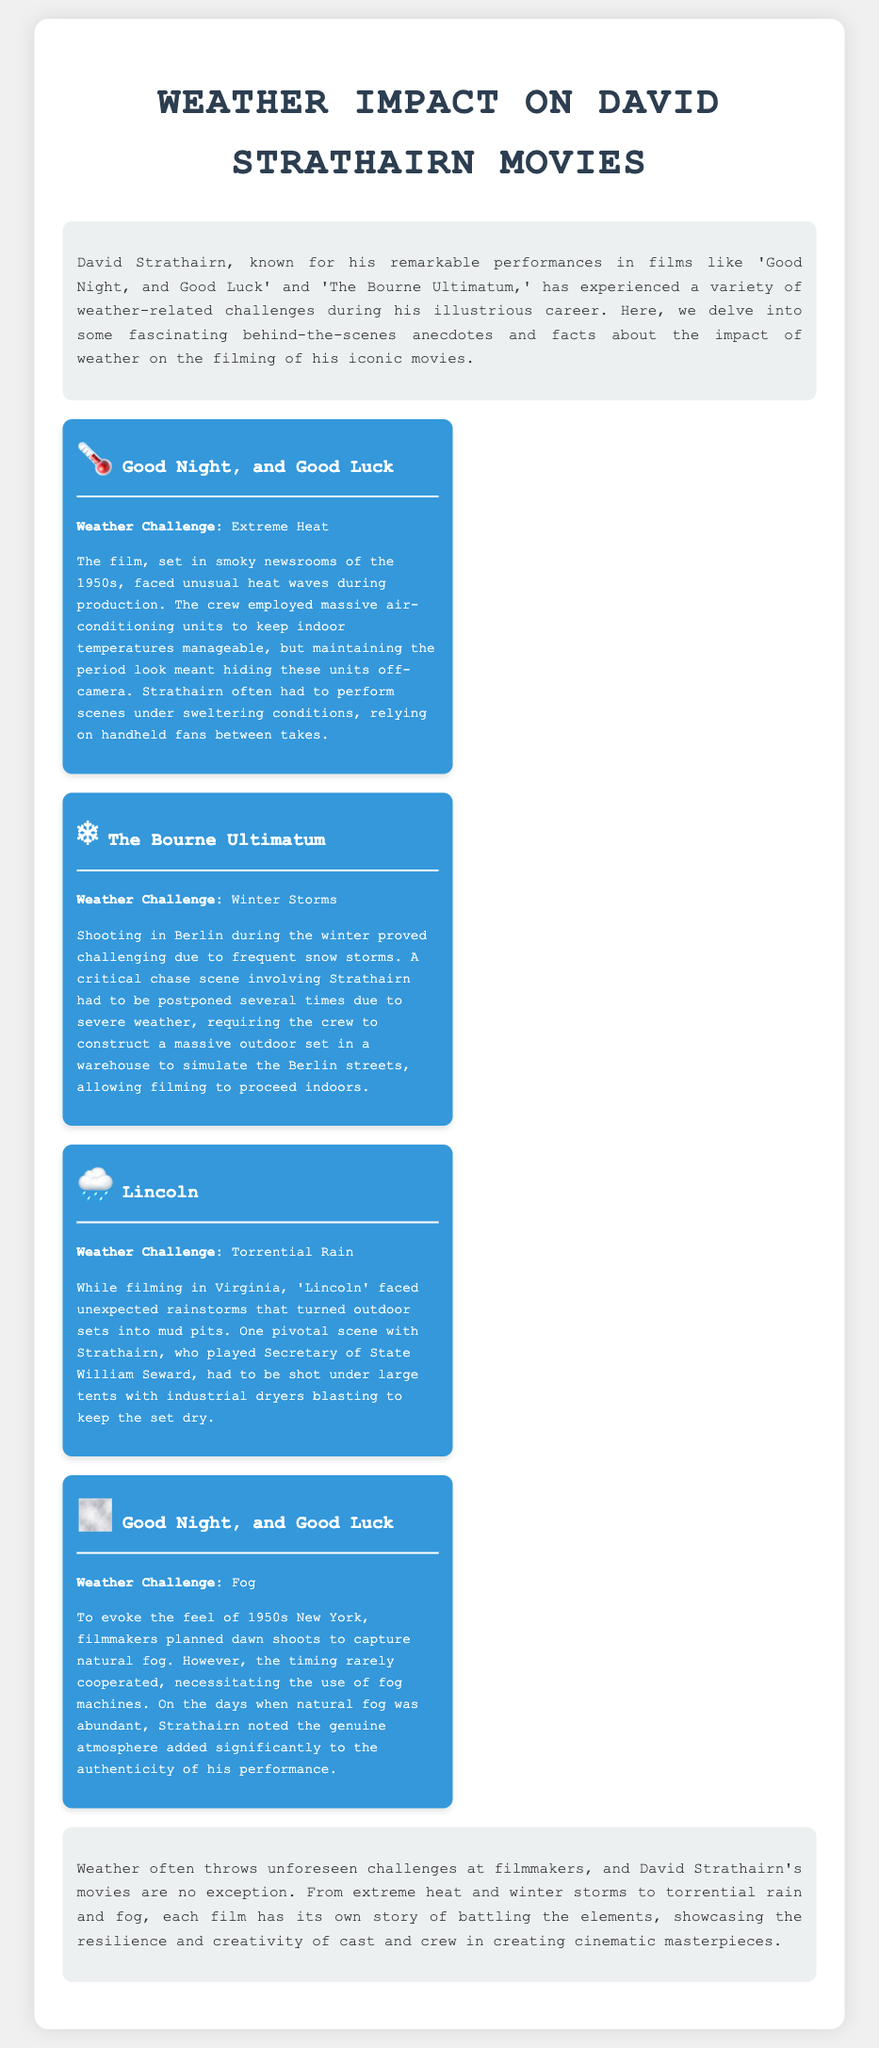What is the title of the movie that faced extreme heat during filming? The document mentions that "Good Night, and Good Luck" faced extreme heat during production.
Answer: Good Night, and Good Luck What type of weather challenge was encountered during the filming of "The Bourne Ultimatum"? The document states that winter storms posed a challenge during the shooting of "The Bourne Ultimatum."
Answer: Winter Storms In which state did the unexpected rainstorms occur while filming "Lincoln"? According to the document, the rainstorms happened in Virginia during the filming of "Lincoln."
Answer: Virginia What was used to keep the outdoor sets dry during filming of "Lincoln"? The document explains that industrial dryers were used to keep the set dry during rainstorms in "Lincoln."
Answer: Industrial Dryers What did filmmakers use when natural fog was unavailable during "Good Night, and Good Luck"? The document states that fog machines were used to create fog when natural fog was not present.
Answer: Fog Machines How many times was a critical chase scene in "The Bourne Ultimatum" postponed? The document indicates that the critical chase scene had to be postponed several times due to severe weather.
Answer: Several times Which film included scenes shot under large tents due to torrential rain? The document specifies that "Lincoln" included scenes shot under large tents because of torrential rain.
Answer: Lincoln What did Strathairn use between takes during the filming of "Good Night, and Good Luck"? The document mentions that Strathairn relied on handheld fans between takes to cool off.
Answer: Handheld Fans 